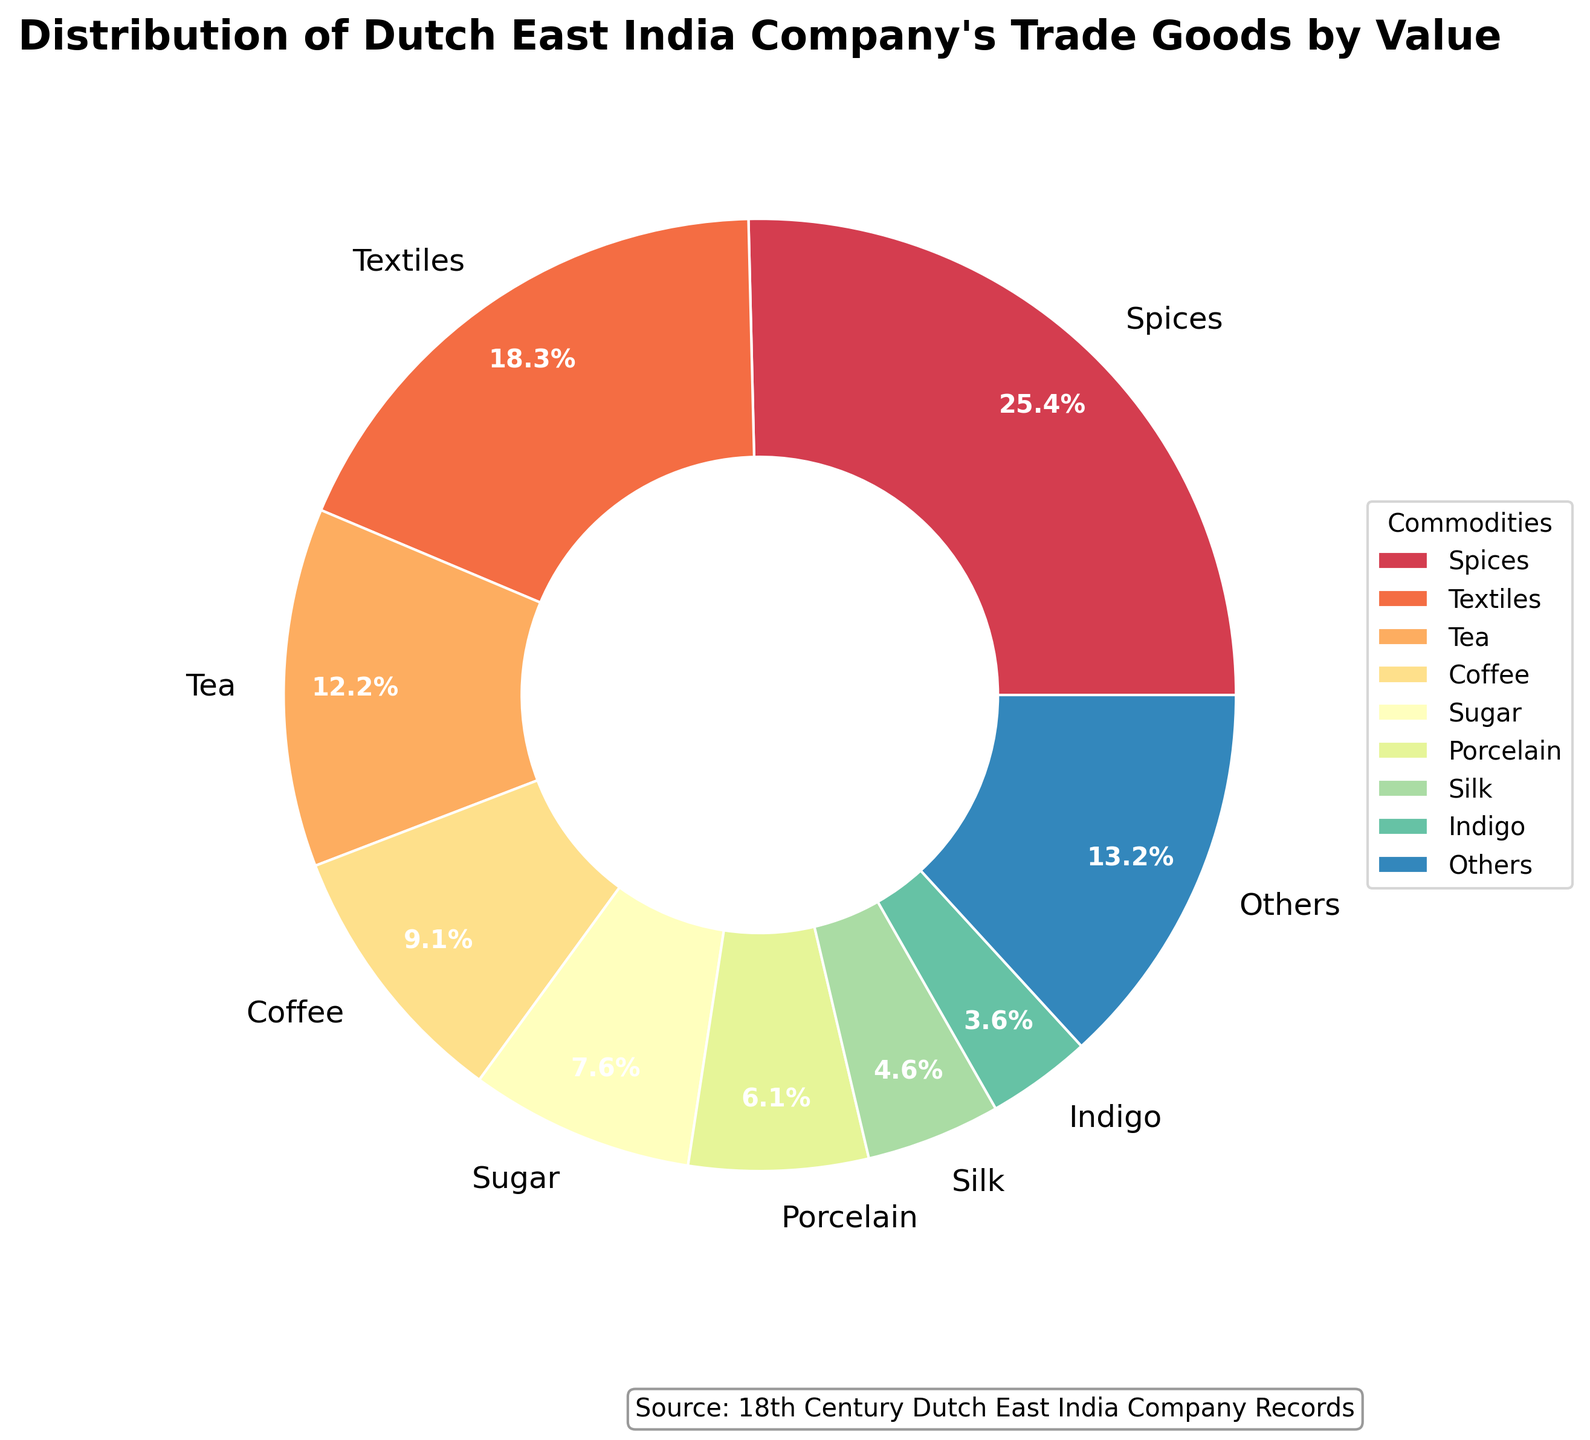Which commodity accounts for the highest value? The figure shows a pie chart with different commodities' portions. The largest portion corresponds to the commodity "Spices".
Answer: Spices What is the combined percentage of Textiles and Tea? Textiles have a value of 18.0%, and Tea has a value of 12.0%. Adding these percentages: 18.0% + 12.0% = 30.0%.
Answer: 30.0% Which commodity has a greater value, Coffee or Sugar, and by how much? The value for Coffee is 9.0%, and for Sugar, it is 7.5%. The difference is 9.0% - 7.5% = 1.5%. Coffee has a greater value by 1.5%.
Answer: Coffee, by 1.5% What percentage of the total value is occupied by Silk, Indigo, and Saltpeter combined? Silk accounts for 4.5%, Indigo for 3.5%, and Saltpeter for 3.0%. Summing them up, 4.5% + 3.5% + 3.0% = 11.0%.
Answer: 11.0% How does the value of Camphor compare to that of Cinnamon? Camphor has a value of 2.5%, and Cinnamon has a value of 1.8%. By comparing, Camphor's value is higher than Cinnamon by 2.5% - 1.8% = 0.7%.
Answer: Camphor is higher by 0.7% Which colors represent the top three commodities? The pie chart uses different colors to represent different commodities. The top three commodities are Spices, Textiles, and Tea. Looking at the pie chart, these likely correspond to the first three distinct segments.
Answer: Colors representing Spices, Textiles, and Tea What portion of the pie chart is labeled as "Others"? According to the data processing, the "Others" category must be the sum of percentages of smaller commodities after the top 8. By looking at the chart, the label "Others" shows a segment with a percentage provided around its wedge.
Answer: Others What is the total percentage occupied by the top two commodities? The top two commodities are Spices and Textiles, representing 25.0% and 18.0% respectively. Adding these gives us 25.0% + 18.0% = 43.0%.
Answer: 43.0% Which is more valuable, Porcelain or Saltpeter, and by how much? Porcelain has a value of 6.0%, while Saltpeter has 3.0%. The difference is calculated by subtraction: 6.0% - 3.0% = 3.0%. Thus, Porcelain is more valuable by 3.0%.
Answer: Porcelain, by 3.0% 